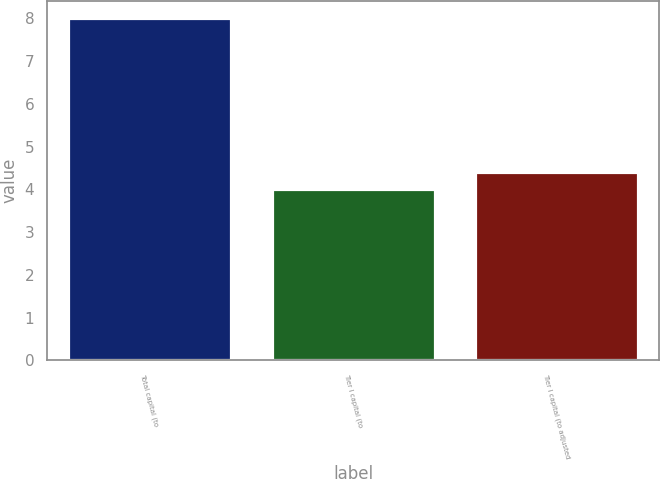<chart> <loc_0><loc_0><loc_500><loc_500><bar_chart><fcel>Total capital (to<fcel>Tier I capital (to<fcel>Tier I capital (to adjusted<nl><fcel>8<fcel>4<fcel>4.4<nl></chart> 